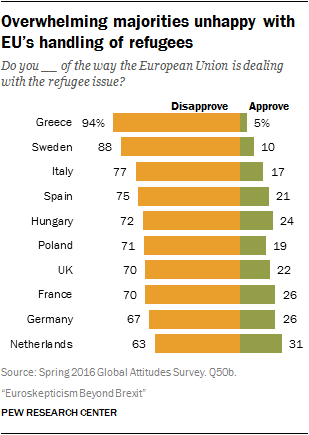Point out several critical features in this image. The value of the third-longest yellow bar is 77. The highest yellow bar and the lowest green bar have a difference of 89. 